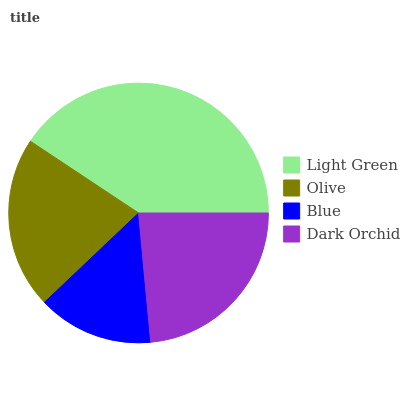Is Blue the minimum?
Answer yes or no. Yes. Is Light Green the maximum?
Answer yes or no. Yes. Is Olive the minimum?
Answer yes or no. No. Is Olive the maximum?
Answer yes or no. No. Is Light Green greater than Olive?
Answer yes or no. Yes. Is Olive less than Light Green?
Answer yes or no. Yes. Is Olive greater than Light Green?
Answer yes or no. No. Is Light Green less than Olive?
Answer yes or no. No. Is Dark Orchid the high median?
Answer yes or no. Yes. Is Olive the low median?
Answer yes or no. Yes. Is Olive the high median?
Answer yes or no. No. Is Blue the low median?
Answer yes or no. No. 